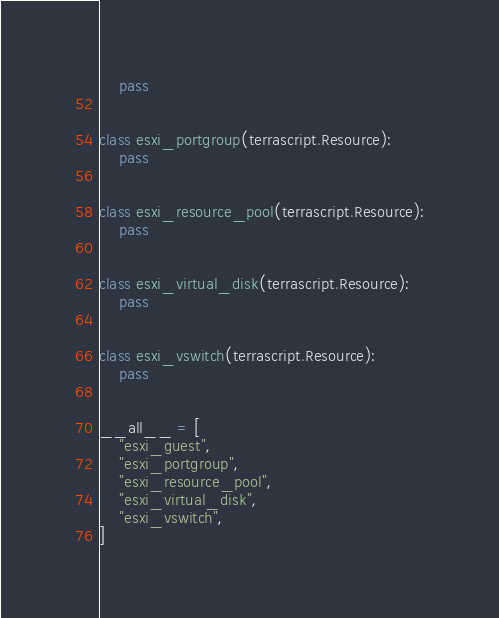<code> <loc_0><loc_0><loc_500><loc_500><_Python_>    pass


class esxi_portgroup(terrascript.Resource):
    pass


class esxi_resource_pool(terrascript.Resource):
    pass


class esxi_virtual_disk(terrascript.Resource):
    pass


class esxi_vswitch(terrascript.Resource):
    pass


__all__ = [
    "esxi_guest",
    "esxi_portgroup",
    "esxi_resource_pool",
    "esxi_virtual_disk",
    "esxi_vswitch",
]
</code> 